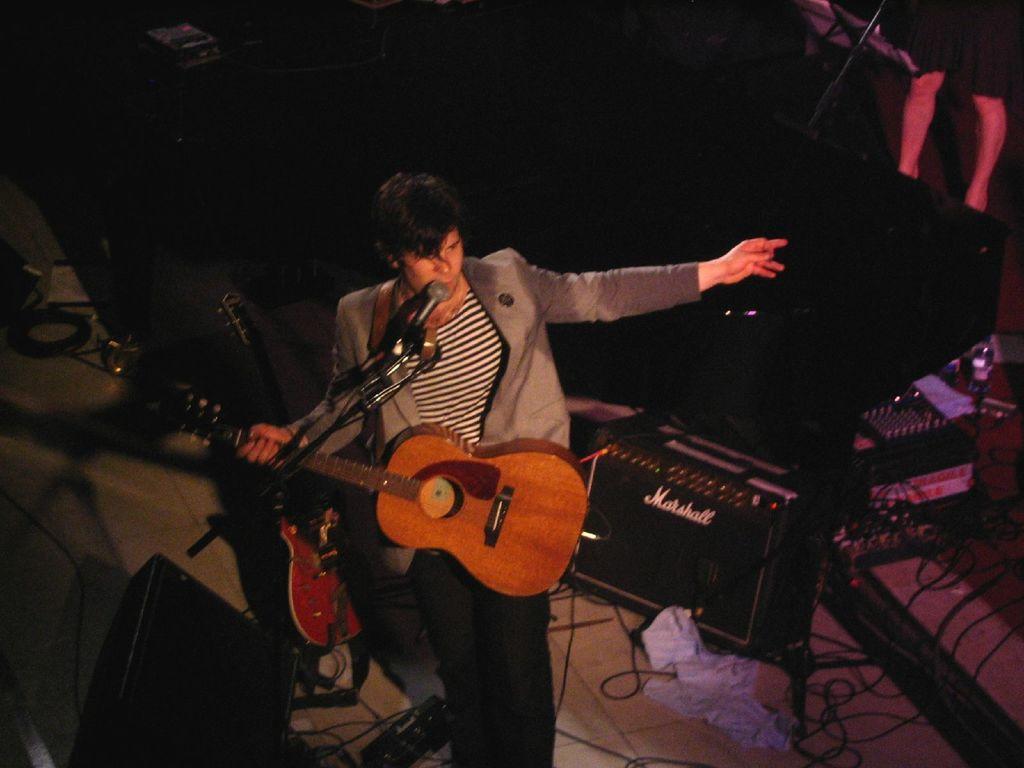Can you describe this image briefly? This person standing and holding guitar,in front of this person we can see microphone with stand. We can see guitar,electrical devices,cables on the floor. On the background we can see person. 